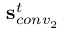Convert formula to latex. <formula><loc_0><loc_0><loc_500><loc_500>s _ { c o n v _ { 2 } } ^ { t }</formula> 